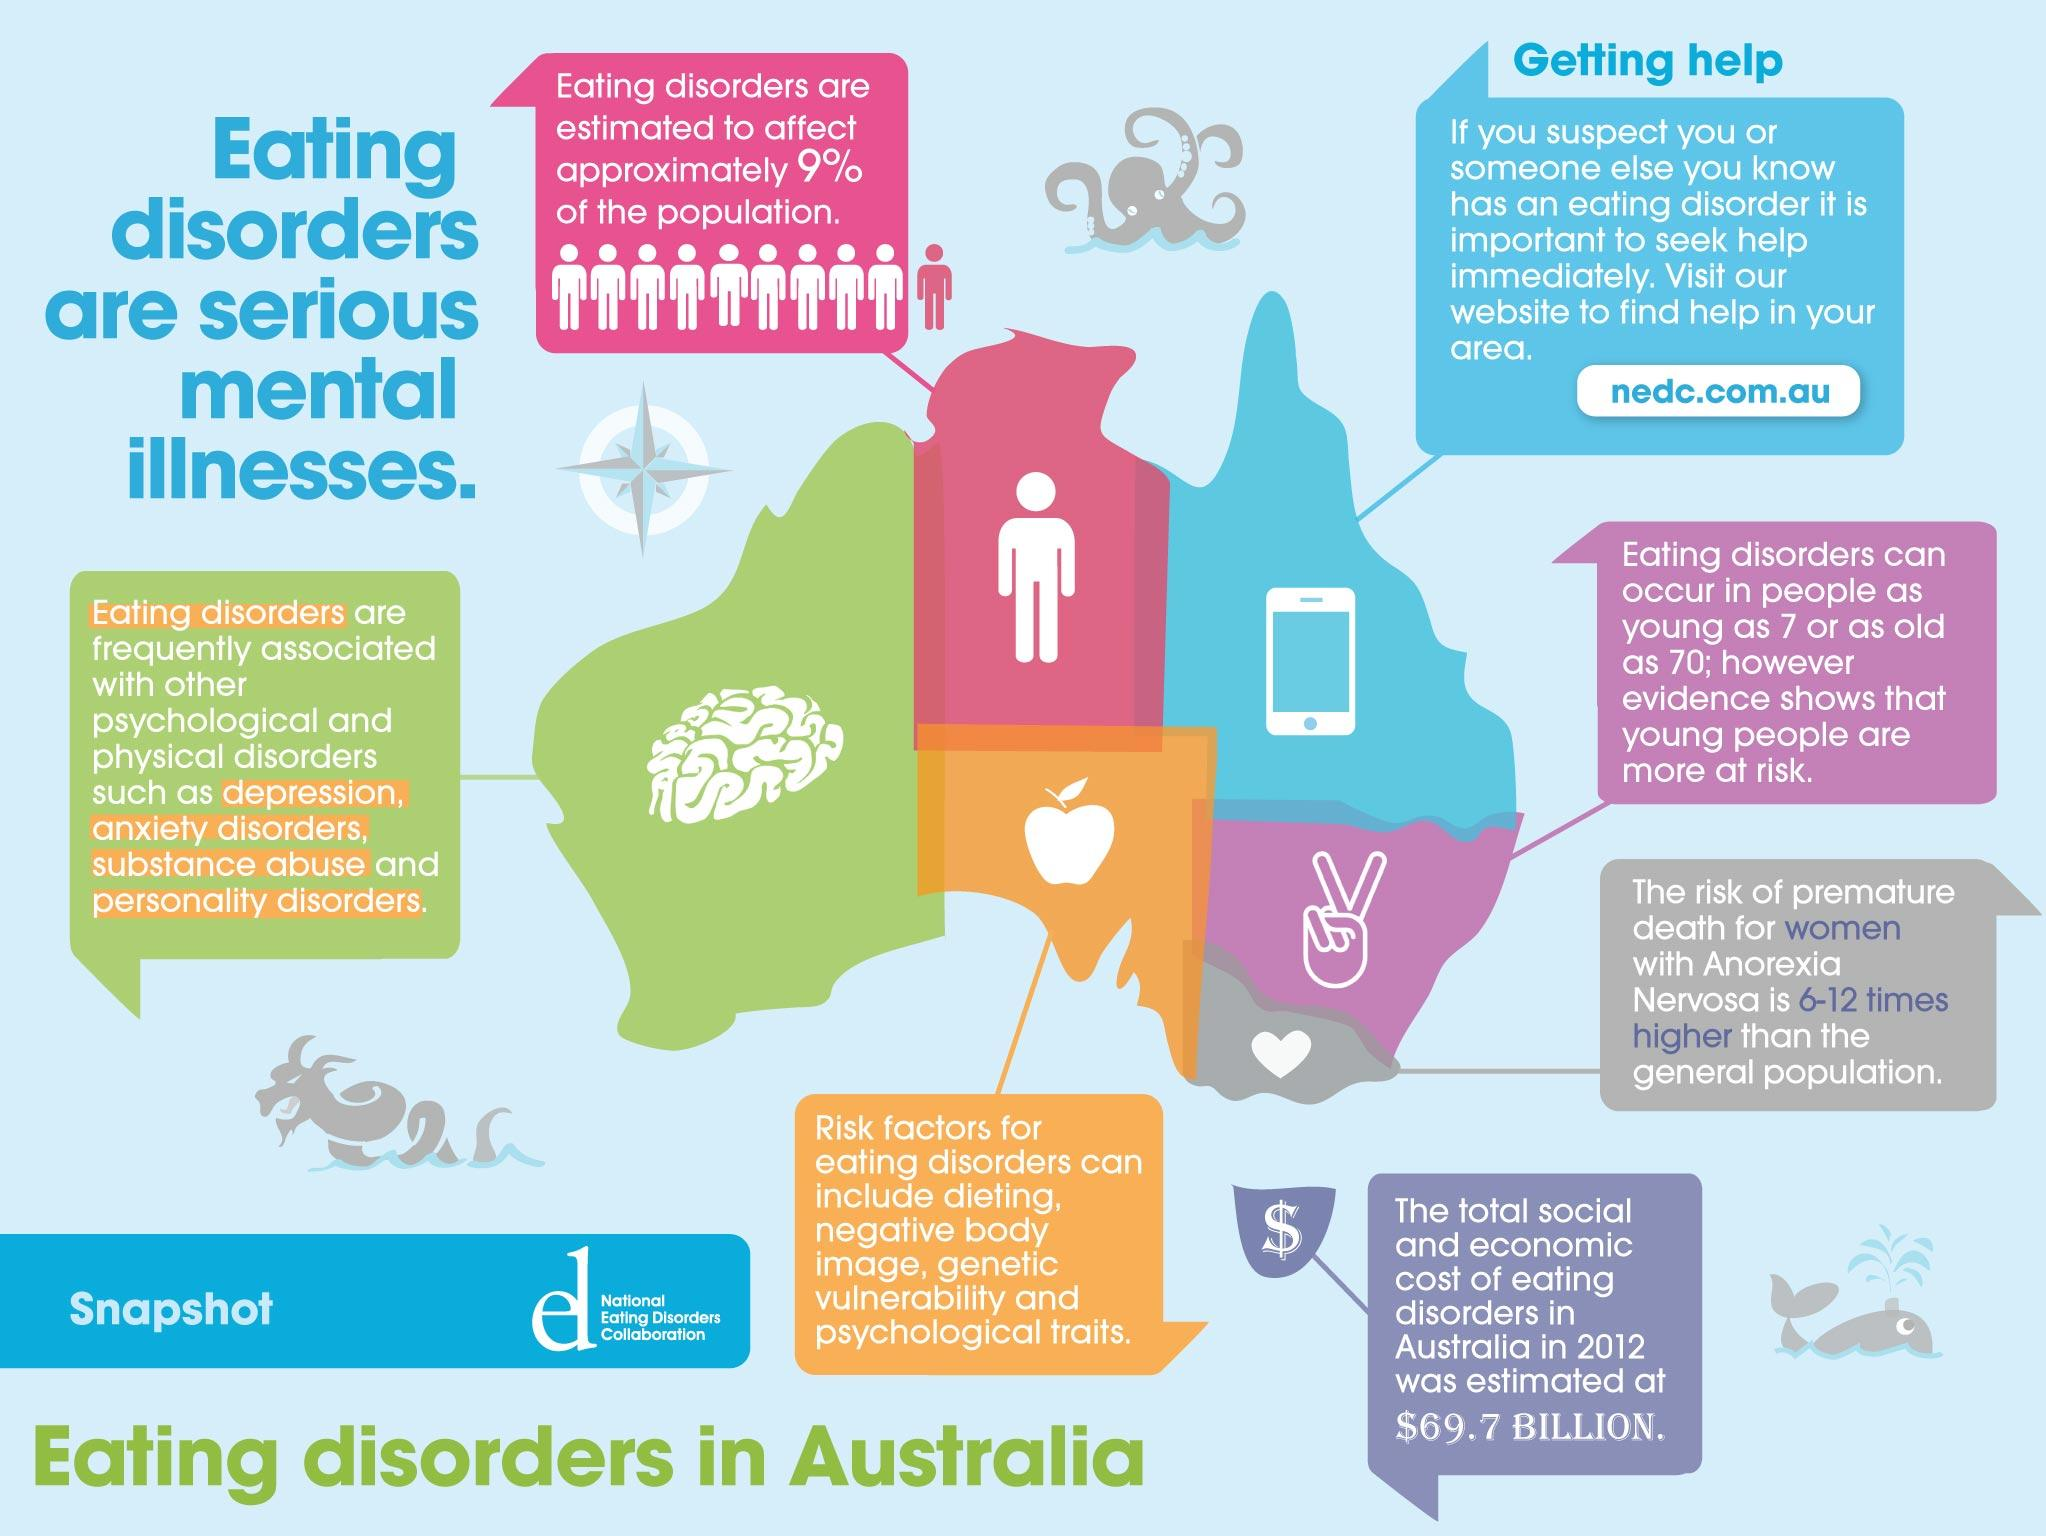Point out several critical features in this image. The individuals who are affected by Anorexia Nervosa are six to twelve times more likely to die prematurely compared to the general population. According to recent data, approximately 9% of the population is affected by eating disorders. Eating disorders can occur in people of any age from 7 to 70 years old. If you are aware that someone has an eating disorder, it is crucial to seek help immediately. According to a study conducted in 2012, the total social and economic cost of eating disorders was estimated to be $69.7 billion. 